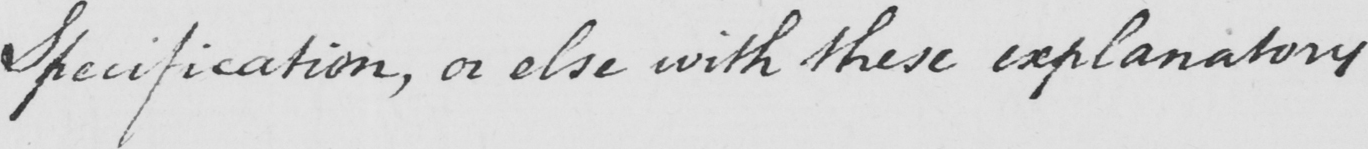Transcribe the text shown in this historical manuscript line. Specification , or else with these explanatory 